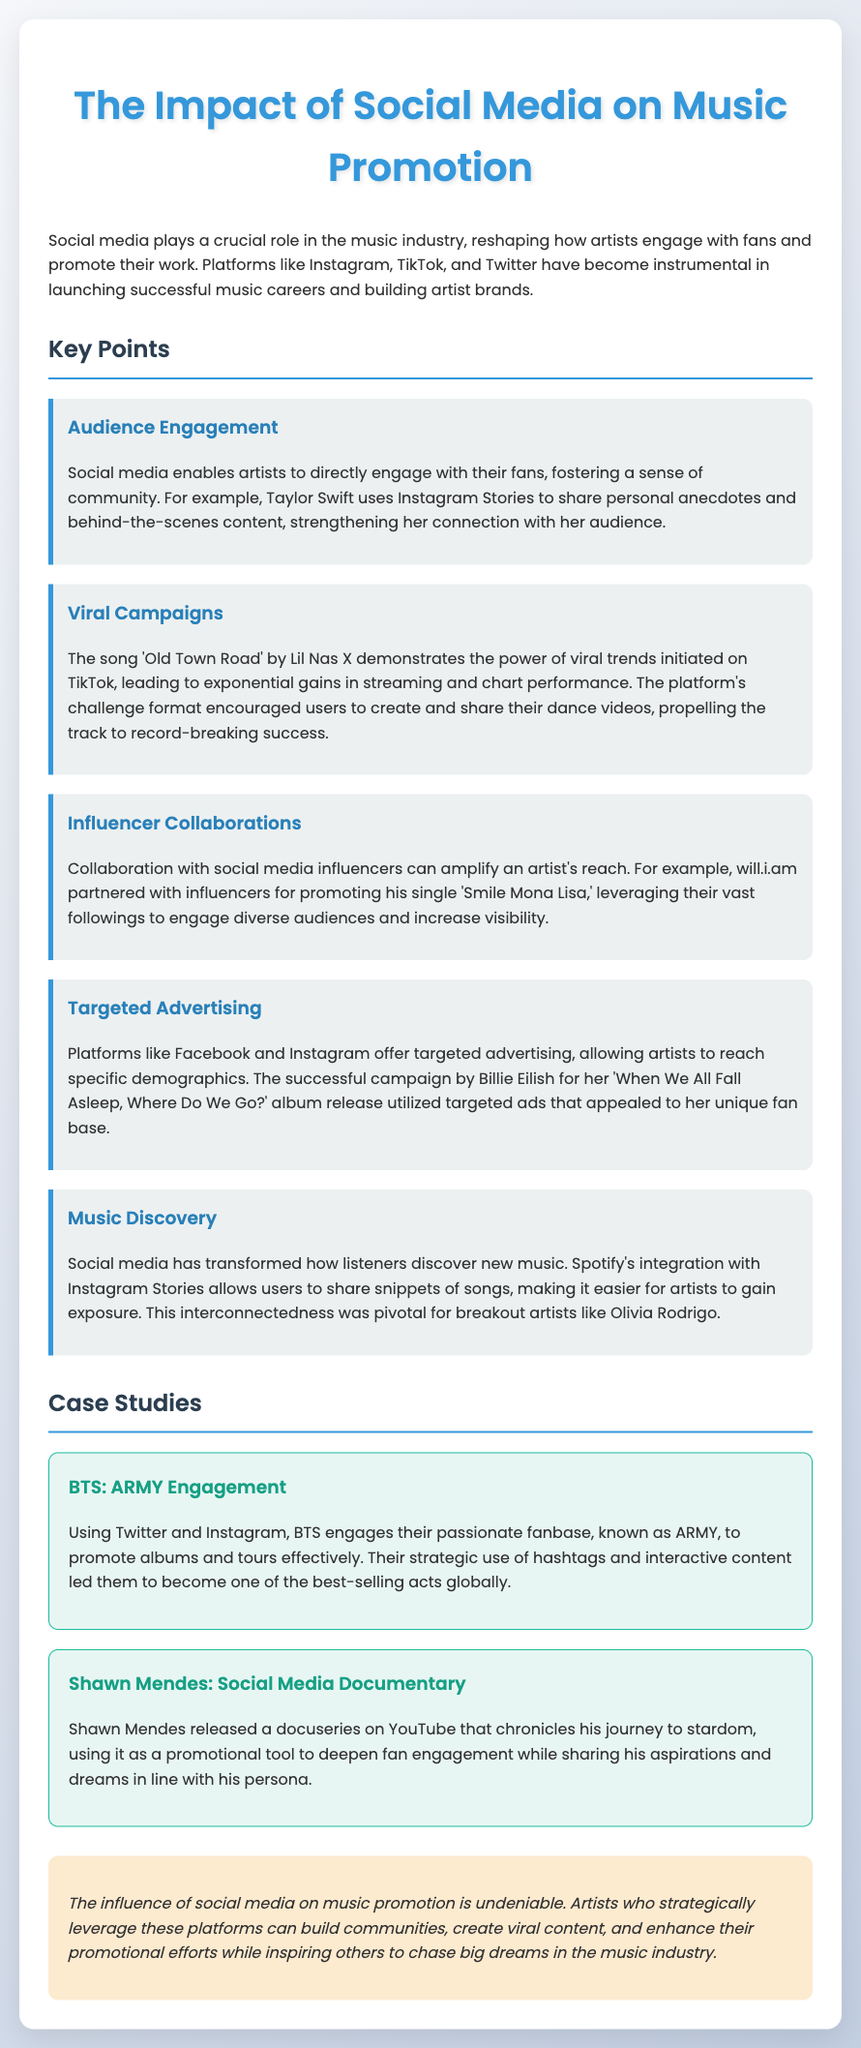What role does social media play in the music industry? The document states that social media plays a crucial role in reshaping how artists engage with fans and promote their work.
Answer: crucial role Which song is mentioned as demonstrating the power of viral trends on TikTok? The song 'Old Town Road' by Lil Nas X is highlighted for its viral success stemming from TikTok.
Answer: Old Town Road Who partnered with influencers to promote 'Smile Mona Lisa'? will.i.am is mentioned as collaborating with influencers for this promotion.
Answer: will.i.am What type of advertising do platforms like Facebook and Instagram provide? The document discusses targeted advertising that allows artists to reach specific demographics.
Answer: targeted advertising Which artist utilized a successful campaign for their album 'When We All Fall Asleep, Where Do We Go?'? Billie Eilish is recognized for her effective use of targeted ads for her album release.
Answer: Billie Eilish What fanbase is BTS known for? BTS engages their passionate fanbase known as ARMY.
Answer: ARMY What promotional tool did Shawn Mendes use to deepen fan engagement? Shawn Mendes released a docuseries on YouTube as a promotional tool.
Answer: docuseries on YouTube How do artists benefit from social media according to the conclusion? The conclusion emphasizes that artists who leverage social media can build communities, create viral content, and enhance promotional efforts.
Answer: build communities, create viral content, enhance promotional efforts 